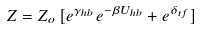<formula> <loc_0><loc_0><loc_500><loc_500>Z = Z _ { o } \, [ e ^ { \gamma _ { h b } } e ^ { - \beta U _ { h b } } + e ^ { \delta _ { t f } } ]</formula> 